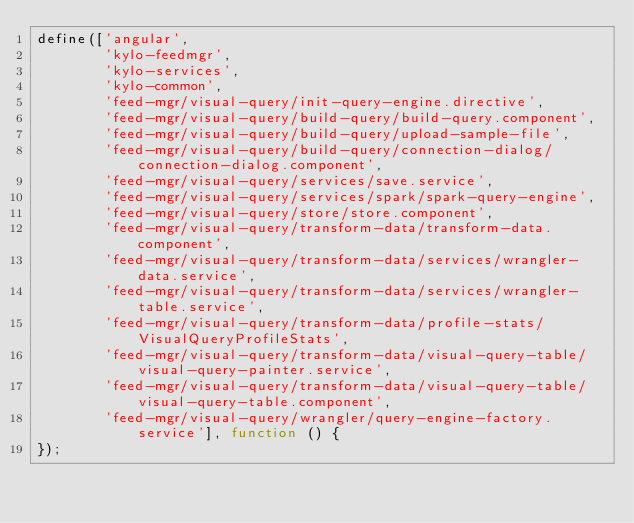Convert code to text. <code><loc_0><loc_0><loc_500><loc_500><_JavaScript_>define(['angular',
        'kylo-feedmgr',
        'kylo-services',
        'kylo-common',
        'feed-mgr/visual-query/init-query-engine.directive',
        'feed-mgr/visual-query/build-query/build-query.component',
        'feed-mgr/visual-query/build-query/upload-sample-file',
        'feed-mgr/visual-query/build-query/connection-dialog/connection-dialog.component',
        'feed-mgr/visual-query/services/save.service',
        'feed-mgr/visual-query/services/spark/spark-query-engine',
        'feed-mgr/visual-query/store/store.component',
        'feed-mgr/visual-query/transform-data/transform-data.component',
        'feed-mgr/visual-query/transform-data/services/wrangler-data.service',
        'feed-mgr/visual-query/transform-data/services/wrangler-table.service',
        'feed-mgr/visual-query/transform-data/profile-stats/VisualQueryProfileStats',
        'feed-mgr/visual-query/transform-data/visual-query-table/visual-query-painter.service',
        'feed-mgr/visual-query/transform-data/visual-query-table/visual-query-table.component',
        'feed-mgr/visual-query/wrangler/query-engine-factory.service'], function () {
});
</code> 